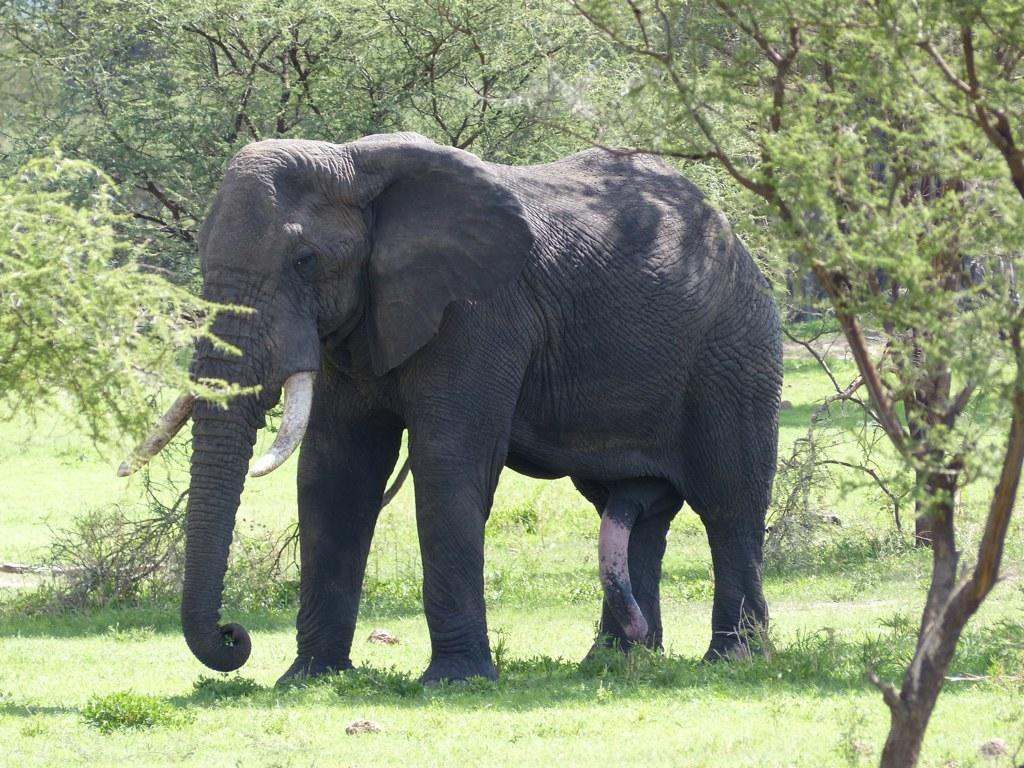In one or two sentences, can you explain what this image depicts? In this picture we can see an elephant standing on the grass and in the background we can see trees. 